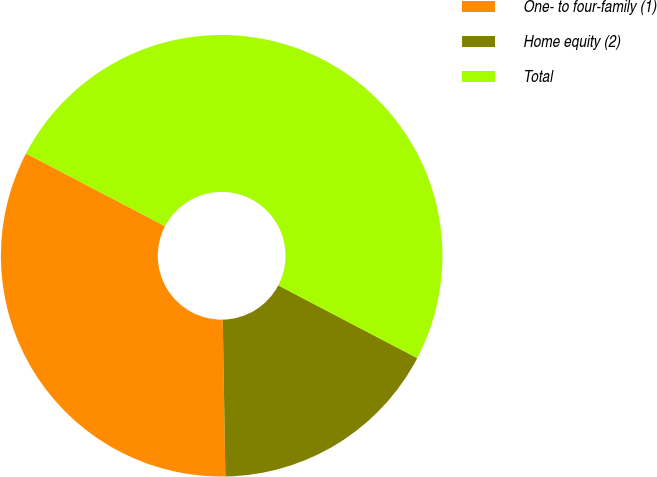<chart> <loc_0><loc_0><loc_500><loc_500><pie_chart><fcel>One- to four-family (1)<fcel>Home equity (2)<fcel>Total<nl><fcel>32.94%<fcel>17.06%<fcel>50.0%<nl></chart> 